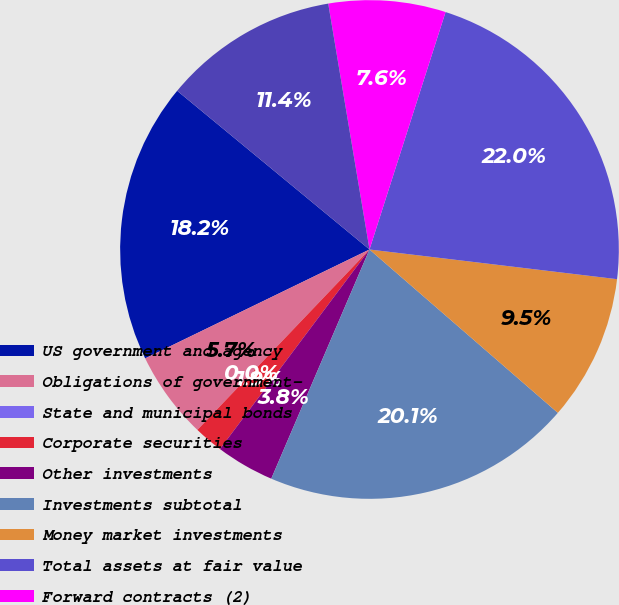<chart> <loc_0><loc_0><loc_500><loc_500><pie_chart><fcel>US government and agency<fcel>Obligations of government-<fcel>State and municipal bonds<fcel>Corporate securities<fcel>Other investments<fcel>Investments subtotal<fcel>Money market investments<fcel>Total assets at fair value<fcel>Forward contracts (2)<fcel>Liabilities related to the<nl><fcel>18.17%<fcel>5.68%<fcel>0.0%<fcel>1.89%<fcel>3.79%<fcel>20.07%<fcel>9.47%<fcel>21.96%<fcel>7.58%<fcel>11.37%<nl></chart> 